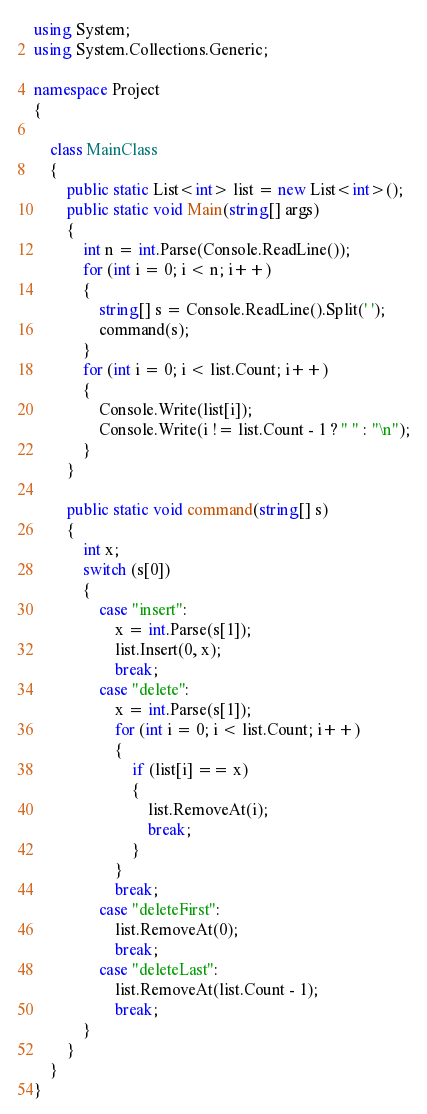<code> <loc_0><loc_0><loc_500><loc_500><_C#_>using System;
using System.Collections.Generic;

namespace Project
{
	
	class MainClass
	{
		public static List<int> list = new List<int>();
		public static void Main(string[] args)
		{
			int n = int.Parse(Console.ReadLine());
			for (int i = 0; i < n; i++)
			{
				string[] s = Console.ReadLine().Split(' ');
				command(s);
			}
			for (int i = 0; i < list.Count; i++)
			{
				Console.Write(list[i]);
				Console.Write(i != list.Count - 1 ? " " : "\n");
			}
		}

		public static void command(string[] s)
		{
			int x;
			switch (s[0])
			{
				case "insert":
					x = int.Parse(s[1]);
					list.Insert(0, x);
					break;
				case "delete":
					x = int.Parse(s[1]);
					for (int i = 0; i < list.Count; i++)
					{
						if (list[i] == x)
						{
							list.RemoveAt(i);
							break;
						}
					}
					break;
				case "deleteFirst":
					list.RemoveAt(0);
					break;
				case "deleteLast":
					list.RemoveAt(list.Count - 1);
					break;
			}
		}
	}
}</code> 